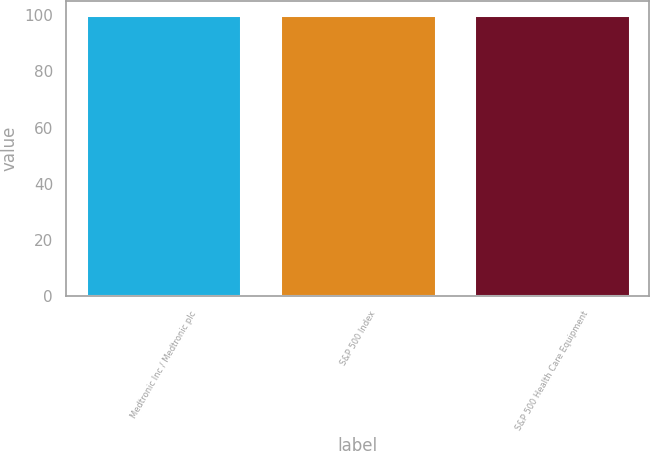<chart> <loc_0><loc_0><loc_500><loc_500><bar_chart><fcel>Medtronic Inc / Medtronic plc<fcel>S&P 500 Index<fcel>S&P 500 Health Care Equipment<nl><fcel>100<fcel>100.1<fcel>100.2<nl></chart> 